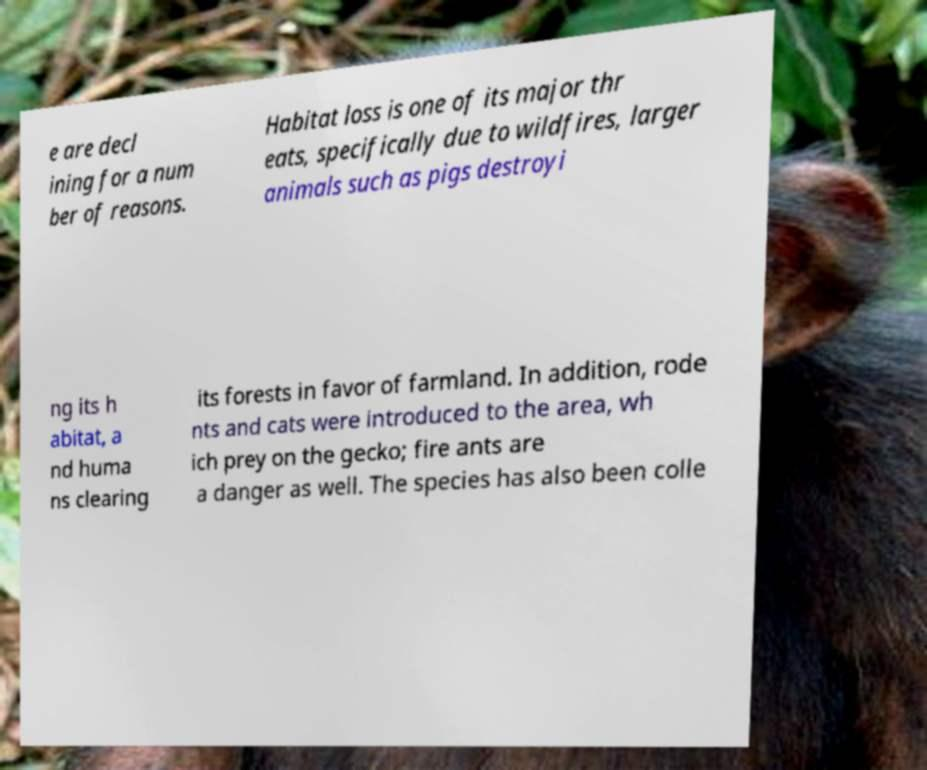I need the written content from this picture converted into text. Can you do that? e are decl ining for a num ber of reasons. Habitat loss is one of its major thr eats, specifically due to wildfires, larger animals such as pigs destroyi ng its h abitat, a nd huma ns clearing its forests in favor of farmland. In addition, rode nts and cats were introduced to the area, wh ich prey on the gecko; fire ants are a danger as well. The species has also been colle 